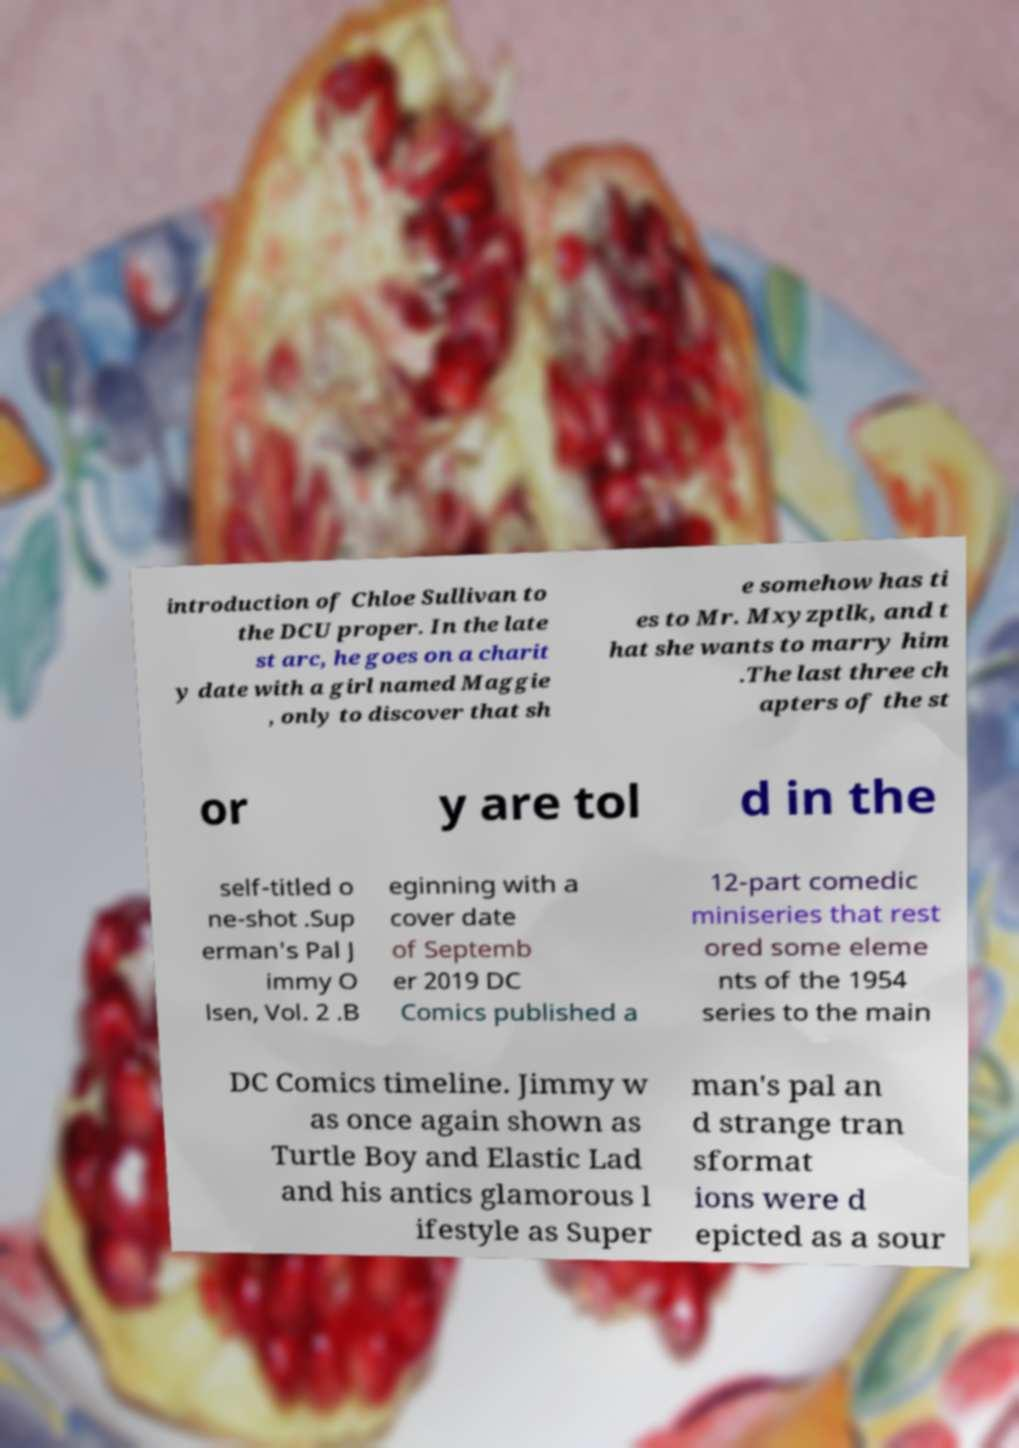I need the written content from this picture converted into text. Can you do that? introduction of Chloe Sullivan to the DCU proper. In the late st arc, he goes on a charit y date with a girl named Maggie , only to discover that sh e somehow has ti es to Mr. Mxyzptlk, and t hat she wants to marry him .The last three ch apters of the st or y are tol d in the self-titled o ne-shot .Sup erman's Pal J immy O lsen, Vol. 2 .B eginning with a cover date of Septemb er 2019 DC Comics published a 12-part comedic miniseries that rest ored some eleme nts of the 1954 series to the main DC Comics timeline. Jimmy w as once again shown as Turtle Boy and Elastic Lad and his antics glamorous l ifestyle as Super man's pal an d strange tran sformat ions were d epicted as a sour 